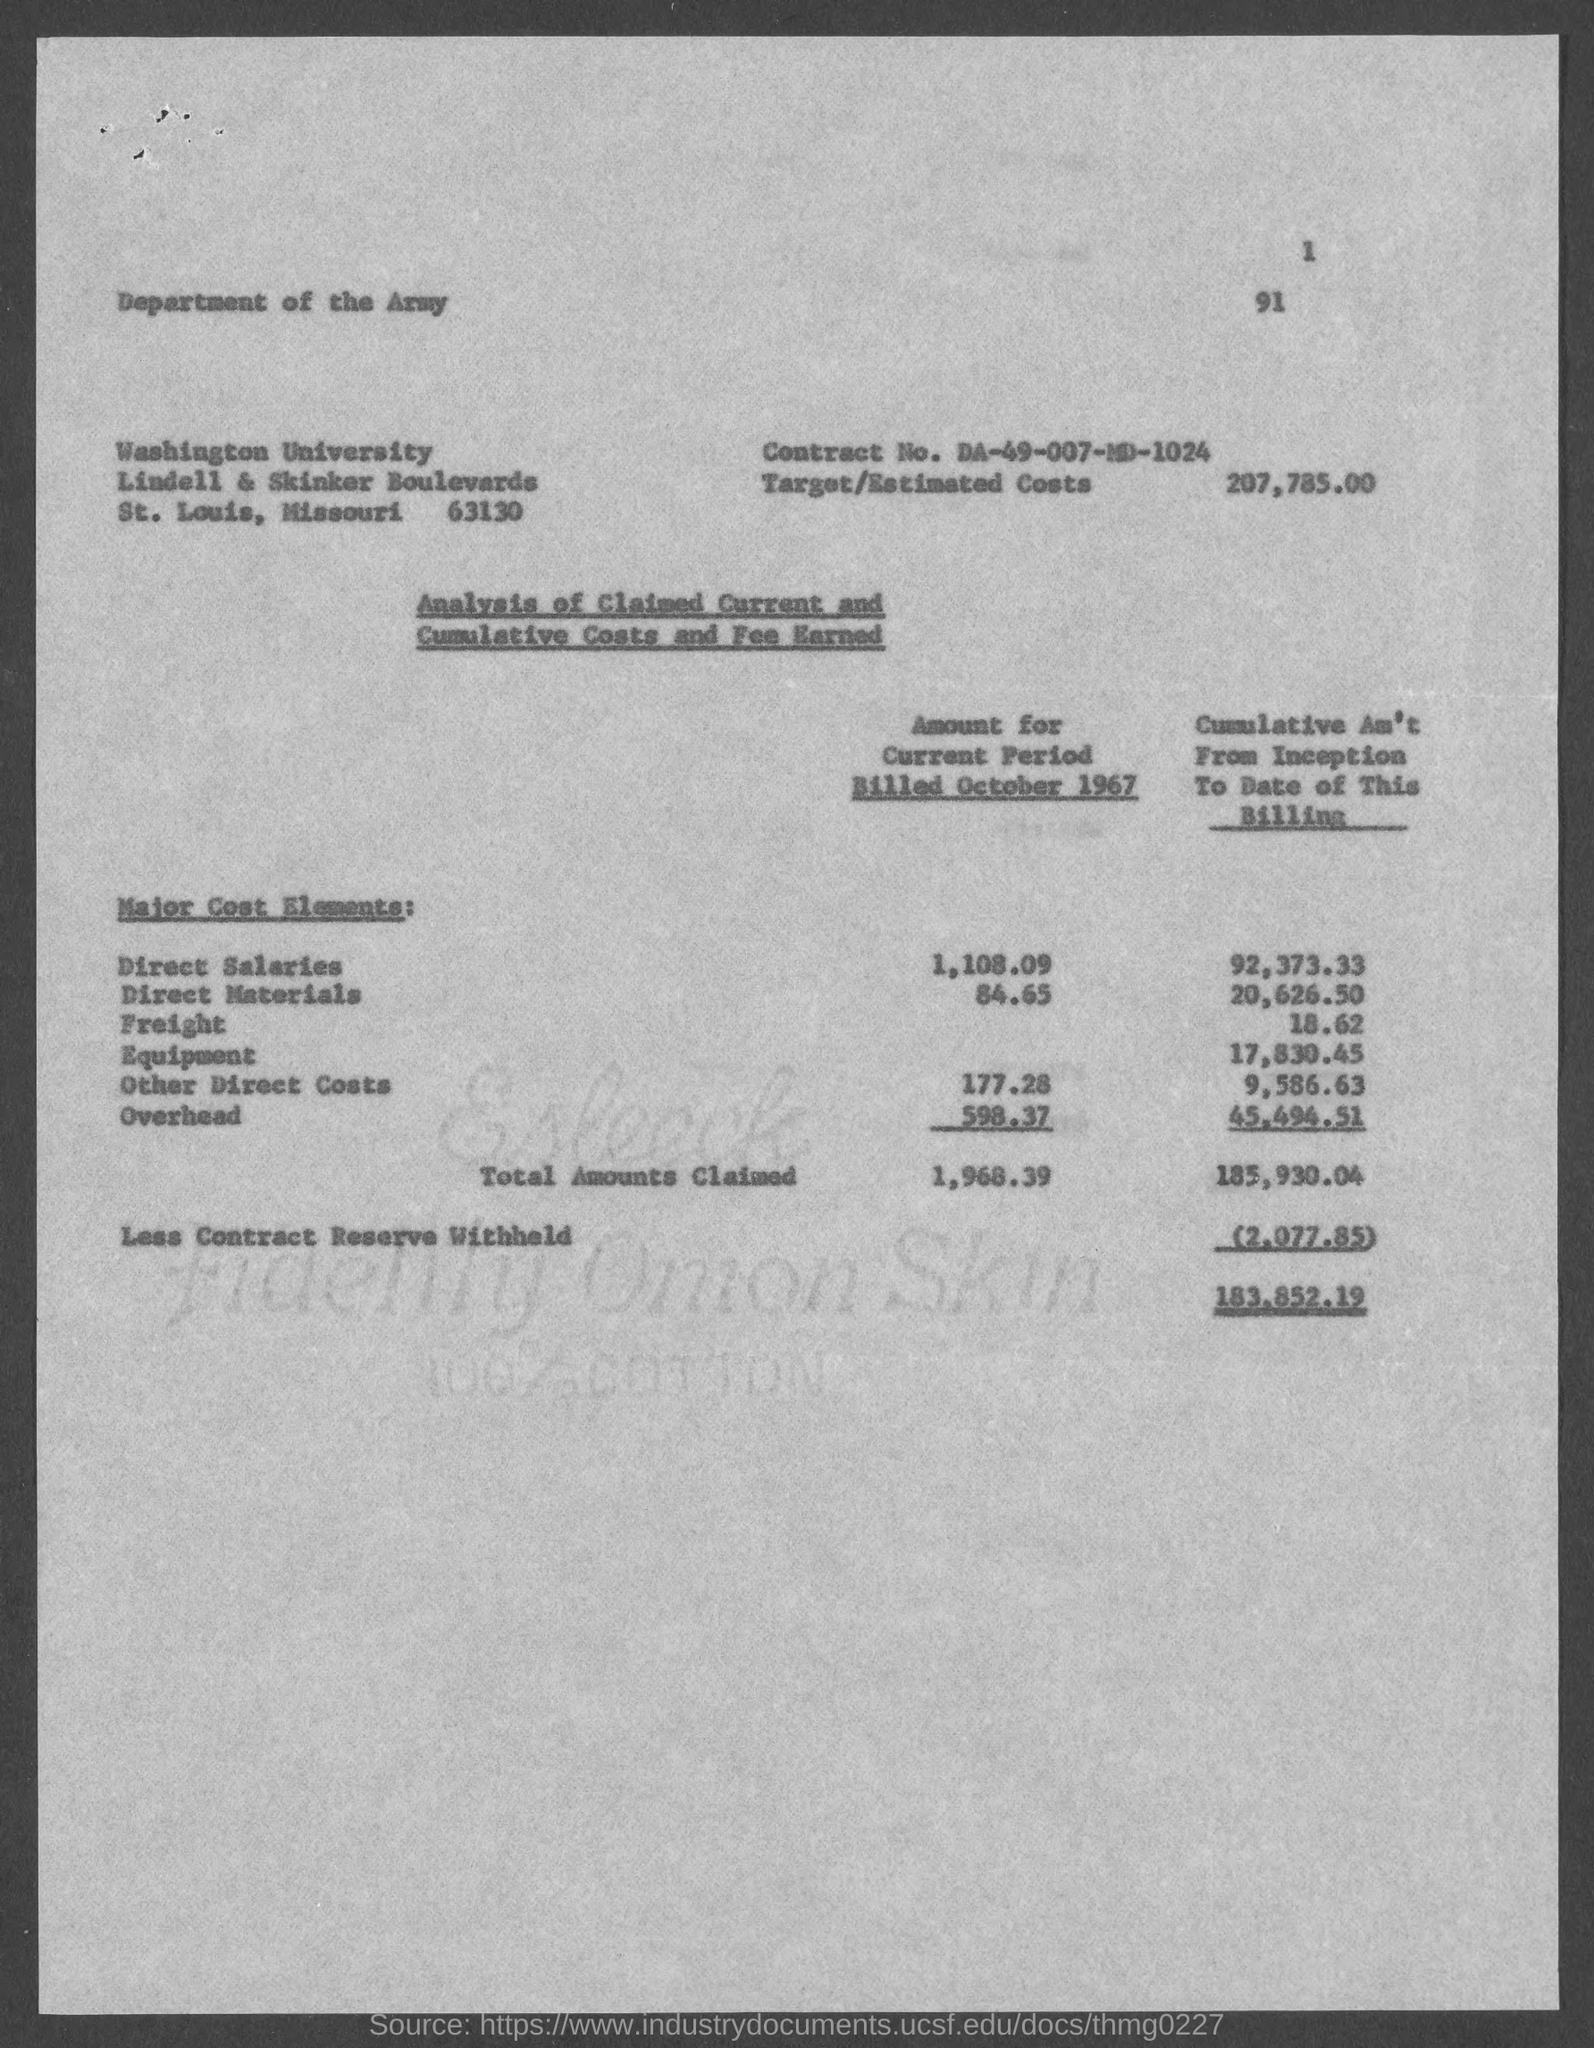What is the contract no.?
Your answer should be compact. DA-49-007-MD-1024. What is the target/estimated costs ?
Offer a terse response. 207,785.00. 